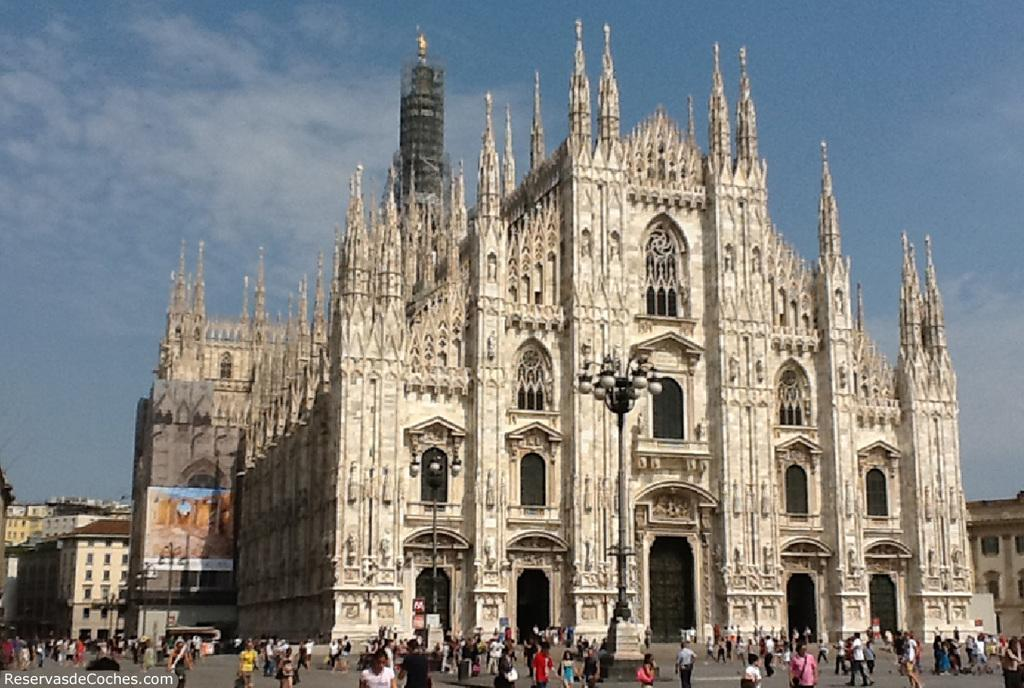What is happening on the road in the image? There are people on the road in the image. What can be seen in the distance behind the people? There are buildings in the background of the image. What is visible in the sky in the background of the image? Clouds are visible in the sky in the background of the image. What type of riddle is being solved by the people on the road in the image? There is no riddle being solved in the image; it simply shows people on the road. Can you see a pipe in the image? There is no pipe present in the image. 